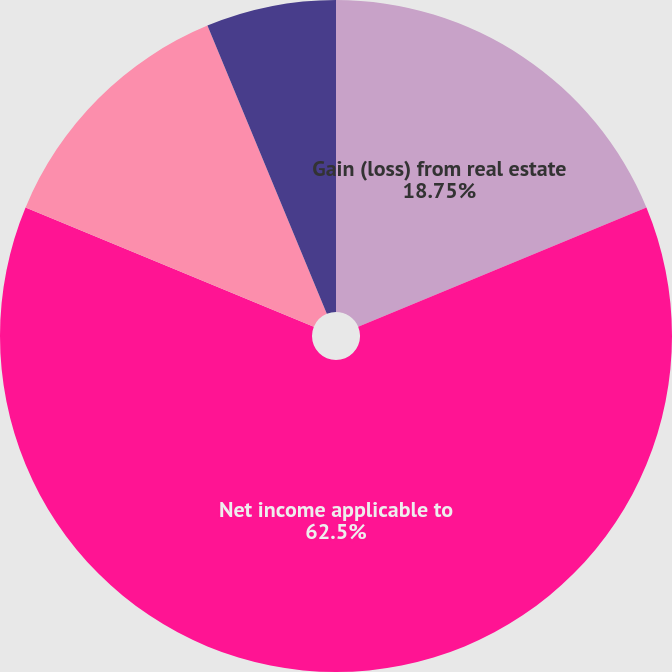Convert chart. <chart><loc_0><loc_0><loc_500><loc_500><pie_chart><fcel>Gain (loss) from real estate<fcel>Net income applicable to<fcel>Dividends paid per common<fcel>Basic earnings per commonshare<fcel>Diluted earnings per<nl><fcel>18.75%<fcel>62.5%<fcel>12.5%<fcel>0.0%<fcel>6.25%<nl></chart> 